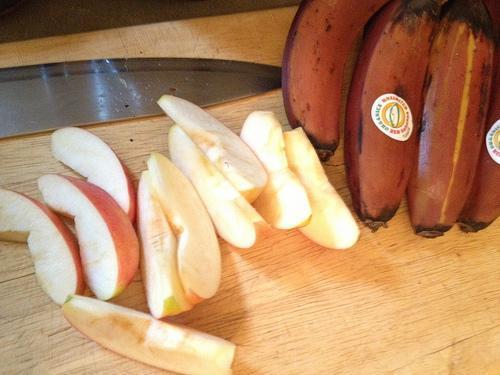How many apple slices?
Give a very brief answer. 10. How many bananas?
Give a very brief answer. 4. How many pieces of fruit aren't apples?
Give a very brief answer. 4. 